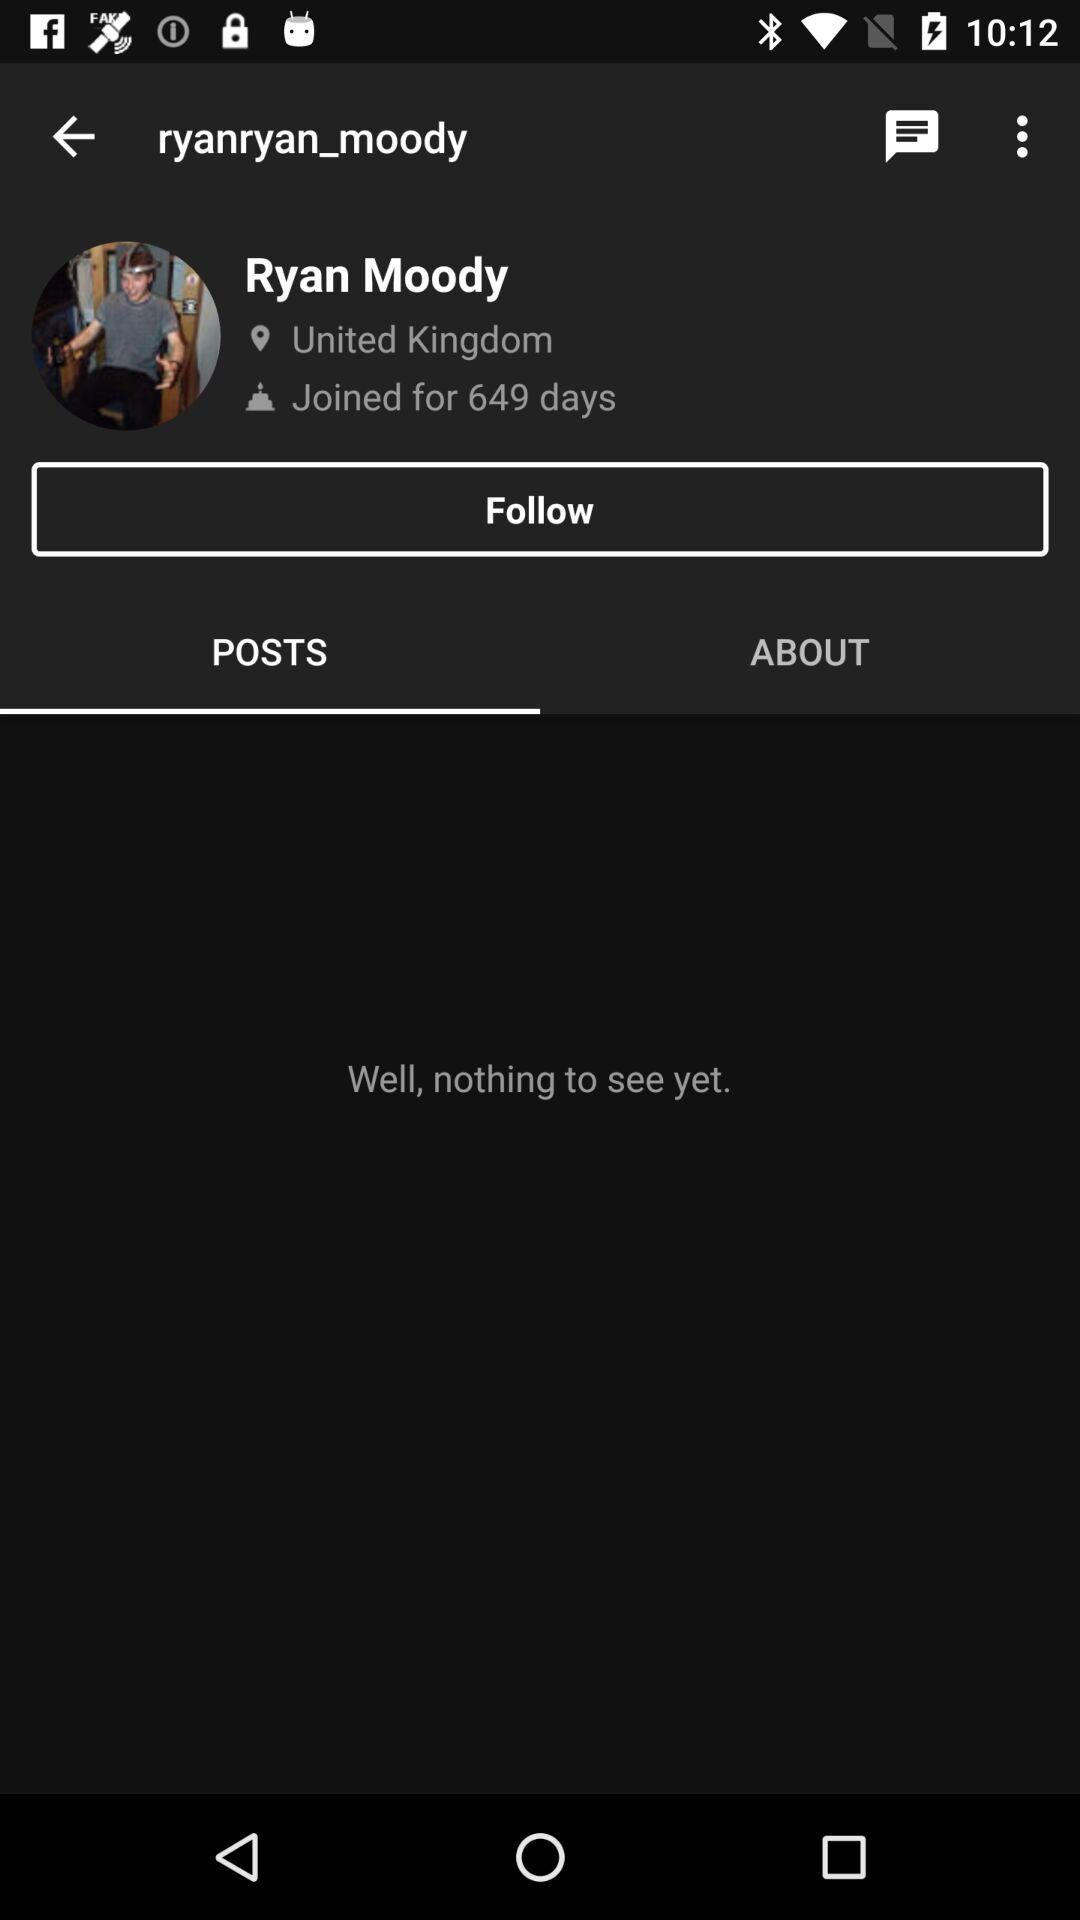How many days has Ryan Moody been on Instagram?
Answer the question using a single word or phrase. 649 